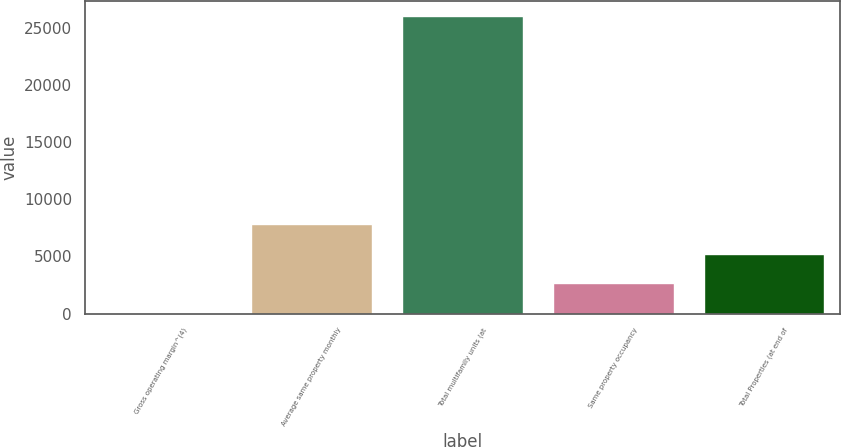<chart> <loc_0><loc_0><loc_500><loc_500><bar_chart><fcel>Gross operating margin^(4)<fcel>Average same property monthly<fcel>Total multifamily units (at<fcel>Same property occupancy<fcel>Total Properties (at end of<nl><fcel>67<fcel>7850.5<fcel>26012<fcel>2661.5<fcel>5256<nl></chart> 